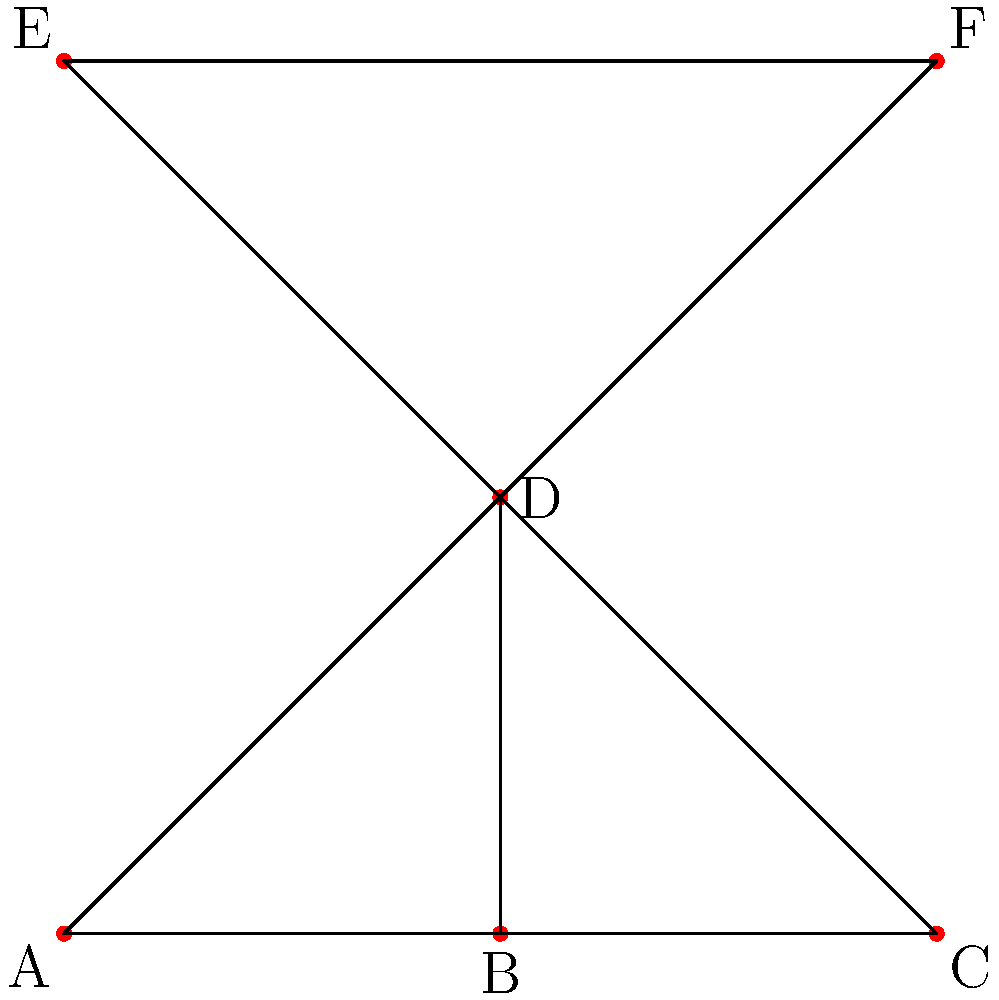In the diagram above, each point represents a music studio in London, and the lines represent direct connections between them. Calculate the Euler characteristic of this network. How does this value relate to the topology of the network, and what might it suggest about the interconnectedness of the UK indie music scene? To calculate the Euler characteristic and understand its implications, let's follow these steps:

1. Count the number of vertices (V):
   There are 6 studios, so V = 6

2. Count the number of edges (E):
   There are 10 connections between studios, so E = 10

3. Count the number of faces (F):
   There are 5 enclosed regions (including the outer face), so F = 5

4. Calculate the Euler characteristic (χ) using the formula:
   χ = V - E + F
   χ = 6 - 10 + 5 = 1

5. Interpret the result:
   - The Euler characteristic of 1 indicates that this network is topologically equivalent to a disk or a plane.
   - This suggests that the network is planar, meaning it can be drawn on a flat surface without any edges crossing.

6. Relate to the UK indie music scene:
   - The planar nature of the network might suggest a well-organized, geographically coherent music scene in London.
   - The interconnectedness (multiple paths between studios) could indicate strong collaboration and information flow within the indie music community.
   - The central studio (D) with many connections might represent a hub or influential player in the scene.
Answer: Euler characteristic: 1 (planar graph, indicating a well-connected, geographically coherent music scene) 